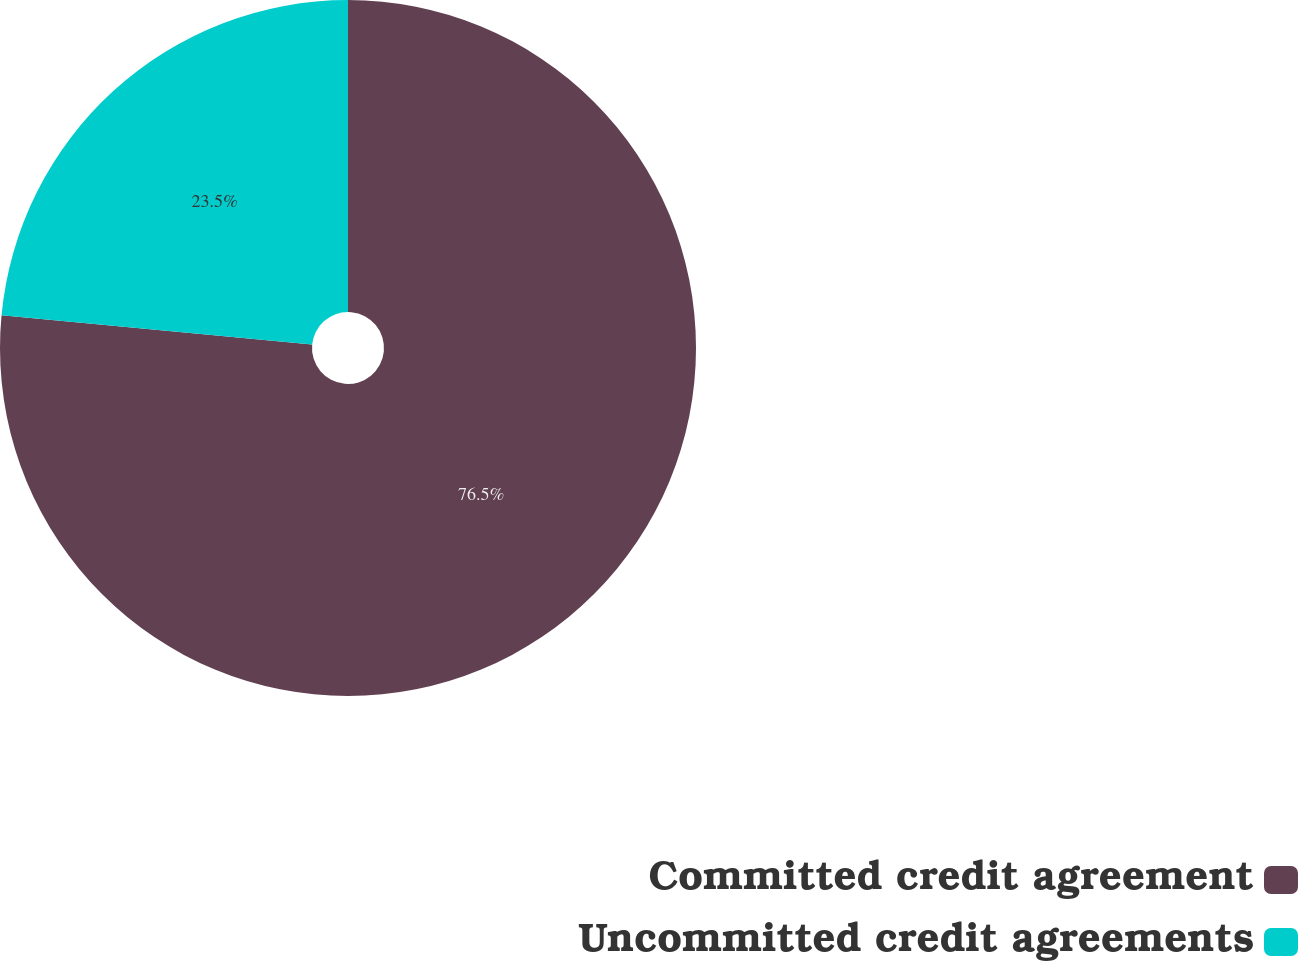Convert chart to OTSL. <chart><loc_0><loc_0><loc_500><loc_500><pie_chart><fcel>Committed credit agreement<fcel>Uncommitted credit agreements<nl><fcel>76.5%<fcel>23.5%<nl></chart> 